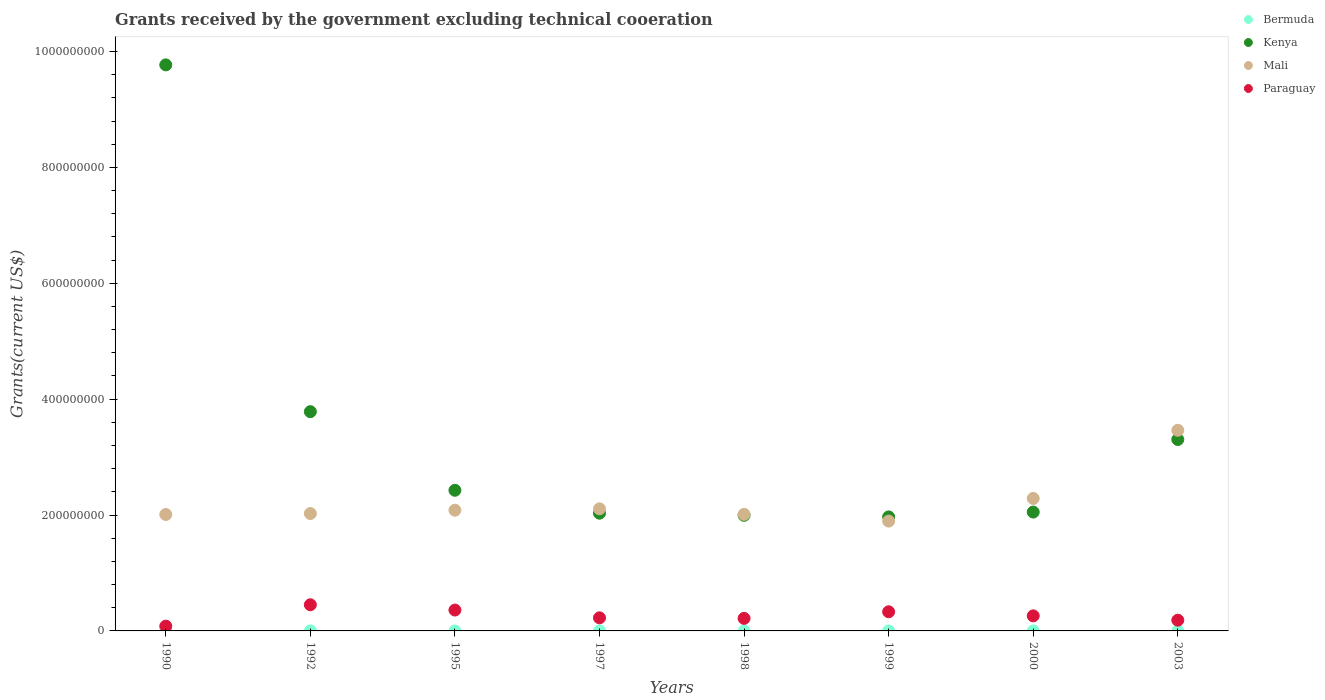What is the total grants received by the government in Paraguay in 1997?
Your response must be concise. 2.26e+07. Across all years, what is the maximum total grants received by the government in Mali?
Give a very brief answer. 3.46e+08. Across all years, what is the minimum total grants received by the government in Paraguay?
Give a very brief answer. 8.24e+06. What is the total total grants received by the government in Kenya in the graph?
Your answer should be compact. 2.73e+09. What is the difference between the total grants received by the government in Kenya in 1990 and that in 1995?
Your response must be concise. 7.34e+08. What is the difference between the total grants received by the government in Kenya in 2003 and the total grants received by the government in Bermuda in 1995?
Offer a very short reply. 3.30e+08. What is the average total grants received by the government in Mali per year?
Provide a short and direct response. 2.24e+08. In the year 1998, what is the difference between the total grants received by the government in Kenya and total grants received by the government in Paraguay?
Keep it short and to the point. 1.78e+08. In how many years, is the total grants received by the government in Paraguay greater than 80000000 US$?
Provide a short and direct response. 0. What is the ratio of the total grants received by the government in Kenya in 1990 to that in 1998?
Provide a short and direct response. 4.9. Is the difference between the total grants received by the government in Kenya in 1990 and 2003 greater than the difference between the total grants received by the government in Paraguay in 1990 and 2003?
Your answer should be very brief. Yes. What is the difference between the highest and the second highest total grants received by the government in Kenya?
Provide a short and direct response. 5.99e+08. What is the difference between the highest and the lowest total grants received by the government in Paraguay?
Ensure brevity in your answer.  3.69e+07. In how many years, is the total grants received by the government in Bermuda greater than the average total grants received by the government in Bermuda taken over all years?
Keep it short and to the point. 2. Is the sum of the total grants received by the government in Mali in 1998 and 1999 greater than the maximum total grants received by the government in Bermuda across all years?
Offer a terse response. Yes. Is it the case that in every year, the sum of the total grants received by the government in Bermuda and total grants received by the government in Paraguay  is greater than the sum of total grants received by the government in Kenya and total grants received by the government in Mali?
Provide a succinct answer. No. Is the total grants received by the government in Bermuda strictly less than the total grants received by the government in Kenya over the years?
Keep it short and to the point. Yes. What is the difference between two consecutive major ticks on the Y-axis?
Ensure brevity in your answer.  2.00e+08. Are the values on the major ticks of Y-axis written in scientific E-notation?
Make the answer very short. No. Does the graph contain grids?
Offer a terse response. No. Where does the legend appear in the graph?
Make the answer very short. Top right. How are the legend labels stacked?
Make the answer very short. Vertical. What is the title of the graph?
Ensure brevity in your answer.  Grants received by the government excluding technical cooeration. Does "Cambodia" appear as one of the legend labels in the graph?
Give a very brief answer. No. What is the label or title of the X-axis?
Your answer should be very brief. Years. What is the label or title of the Y-axis?
Provide a succinct answer. Grants(current US$). What is the Grants(current US$) in Kenya in 1990?
Make the answer very short. 9.77e+08. What is the Grants(current US$) in Mali in 1990?
Offer a terse response. 2.01e+08. What is the Grants(current US$) in Paraguay in 1990?
Provide a succinct answer. 8.24e+06. What is the Grants(current US$) in Bermuda in 1992?
Your answer should be compact. 1.10e+05. What is the Grants(current US$) of Kenya in 1992?
Your answer should be very brief. 3.78e+08. What is the Grants(current US$) in Mali in 1992?
Provide a succinct answer. 2.03e+08. What is the Grants(current US$) of Paraguay in 1992?
Your answer should be very brief. 4.51e+07. What is the Grants(current US$) of Kenya in 1995?
Provide a succinct answer. 2.43e+08. What is the Grants(current US$) in Mali in 1995?
Your answer should be compact. 2.08e+08. What is the Grants(current US$) of Paraguay in 1995?
Offer a very short reply. 3.60e+07. What is the Grants(current US$) in Kenya in 1997?
Give a very brief answer. 2.03e+08. What is the Grants(current US$) of Mali in 1997?
Keep it short and to the point. 2.11e+08. What is the Grants(current US$) of Paraguay in 1997?
Offer a very short reply. 2.26e+07. What is the Grants(current US$) of Bermuda in 1998?
Offer a terse response. 10000. What is the Grants(current US$) in Kenya in 1998?
Make the answer very short. 2.00e+08. What is the Grants(current US$) of Mali in 1998?
Keep it short and to the point. 2.01e+08. What is the Grants(current US$) of Paraguay in 1998?
Make the answer very short. 2.17e+07. What is the Grants(current US$) of Bermuda in 1999?
Offer a very short reply. 10000. What is the Grants(current US$) of Kenya in 1999?
Your answer should be very brief. 1.97e+08. What is the Grants(current US$) of Mali in 1999?
Make the answer very short. 1.90e+08. What is the Grants(current US$) of Paraguay in 1999?
Offer a terse response. 3.30e+07. What is the Grants(current US$) of Bermuda in 2000?
Your answer should be compact. 3.00e+04. What is the Grants(current US$) of Kenya in 2000?
Offer a very short reply. 2.05e+08. What is the Grants(current US$) in Mali in 2000?
Your response must be concise. 2.29e+08. What is the Grants(current US$) of Paraguay in 2000?
Your answer should be very brief. 2.60e+07. What is the Grants(current US$) in Bermuda in 2003?
Ensure brevity in your answer.  10000. What is the Grants(current US$) in Kenya in 2003?
Provide a succinct answer. 3.30e+08. What is the Grants(current US$) in Mali in 2003?
Your answer should be compact. 3.46e+08. What is the Grants(current US$) of Paraguay in 2003?
Your answer should be compact. 1.85e+07. Across all years, what is the maximum Grants(current US$) in Kenya?
Provide a short and direct response. 9.77e+08. Across all years, what is the maximum Grants(current US$) in Mali?
Provide a short and direct response. 3.46e+08. Across all years, what is the maximum Grants(current US$) in Paraguay?
Your answer should be very brief. 4.51e+07. Across all years, what is the minimum Grants(current US$) in Kenya?
Give a very brief answer. 1.97e+08. Across all years, what is the minimum Grants(current US$) in Mali?
Offer a terse response. 1.90e+08. Across all years, what is the minimum Grants(current US$) in Paraguay?
Your answer should be compact. 8.24e+06. What is the total Grants(current US$) in Bermuda in the graph?
Your answer should be very brief. 2.80e+05. What is the total Grants(current US$) in Kenya in the graph?
Your response must be concise. 2.73e+09. What is the total Grants(current US$) in Mali in the graph?
Keep it short and to the point. 1.79e+09. What is the total Grants(current US$) of Paraguay in the graph?
Keep it short and to the point. 2.11e+08. What is the difference between the Grants(current US$) in Bermuda in 1990 and that in 1992?
Offer a terse response. -10000. What is the difference between the Grants(current US$) in Kenya in 1990 and that in 1992?
Your answer should be very brief. 5.99e+08. What is the difference between the Grants(current US$) of Mali in 1990 and that in 1992?
Your answer should be very brief. -1.66e+06. What is the difference between the Grants(current US$) of Paraguay in 1990 and that in 1992?
Your response must be concise. -3.69e+07. What is the difference between the Grants(current US$) of Kenya in 1990 and that in 1995?
Your answer should be very brief. 7.34e+08. What is the difference between the Grants(current US$) of Mali in 1990 and that in 1995?
Your response must be concise. -7.42e+06. What is the difference between the Grants(current US$) of Paraguay in 1990 and that in 1995?
Offer a very short reply. -2.78e+07. What is the difference between the Grants(current US$) of Bermuda in 1990 and that in 1997?
Provide a short and direct response. 9.00e+04. What is the difference between the Grants(current US$) of Kenya in 1990 and that in 1997?
Provide a short and direct response. 7.74e+08. What is the difference between the Grants(current US$) of Mali in 1990 and that in 1997?
Give a very brief answer. -9.80e+06. What is the difference between the Grants(current US$) in Paraguay in 1990 and that in 1997?
Make the answer very short. -1.44e+07. What is the difference between the Grants(current US$) of Kenya in 1990 and that in 1998?
Offer a terse response. 7.77e+08. What is the difference between the Grants(current US$) of Mali in 1990 and that in 1998?
Offer a very short reply. -2.20e+05. What is the difference between the Grants(current US$) of Paraguay in 1990 and that in 1998?
Your response must be concise. -1.34e+07. What is the difference between the Grants(current US$) of Kenya in 1990 and that in 1999?
Your response must be concise. 7.80e+08. What is the difference between the Grants(current US$) in Mali in 1990 and that in 1999?
Make the answer very short. 1.14e+07. What is the difference between the Grants(current US$) of Paraguay in 1990 and that in 1999?
Provide a succinct answer. -2.48e+07. What is the difference between the Grants(current US$) of Kenya in 1990 and that in 2000?
Provide a succinct answer. 7.72e+08. What is the difference between the Grants(current US$) of Mali in 1990 and that in 2000?
Keep it short and to the point. -2.77e+07. What is the difference between the Grants(current US$) in Paraguay in 1990 and that in 2000?
Give a very brief answer. -1.78e+07. What is the difference between the Grants(current US$) in Kenya in 1990 and that in 2003?
Your response must be concise. 6.47e+08. What is the difference between the Grants(current US$) in Mali in 1990 and that in 2003?
Your response must be concise. -1.45e+08. What is the difference between the Grants(current US$) in Paraguay in 1990 and that in 2003?
Ensure brevity in your answer.  -1.03e+07. What is the difference between the Grants(current US$) of Kenya in 1992 and that in 1995?
Provide a succinct answer. 1.36e+08. What is the difference between the Grants(current US$) in Mali in 1992 and that in 1995?
Provide a succinct answer. -5.76e+06. What is the difference between the Grants(current US$) in Paraguay in 1992 and that in 1995?
Keep it short and to the point. 9.10e+06. What is the difference between the Grants(current US$) in Bermuda in 1992 and that in 1997?
Give a very brief answer. 1.00e+05. What is the difference between the Grants(current US$) of Kenya in 1992 and that in 1997?
Ensure brevity in your answer.  1.75e+08. What is the difference between the Grants(current US$) in Mali in 1992 and that in 1997?
Ensure brevity in your answer.  -8.14e+06. What is the difference between the Grants(current US$) of Paraguay in 1992 and that in 1997?
Offer a terse response. 2.25e+07. What is the difference between the Grants(current US$) of Bermuda in 1992 and that in 1998?
Your answer should be compact. 1.00e+05. What is the difference between the Grants(current US$) in Kenya in 1992 and that in 1998?
Offer a terse response. 1.79e+08. What is the difference between the Grants(current US$) in Mali in 1992 and that in 1998?
Offer a very short reply. 1.44e+06. What is the difference between the Grants(current US$) in Paraguay in 1992 and that in 1998?
Your answer should be compact. 2.35e+07. What is the difference between the Grants(current US$) of Kenya in 1992 and that in 1999?
Your answer should be compact. 1.82e+08. What is the difference between the Grants(current US$) of Mali in 1992 and that in 1999?
Give a very brief answer. 1.31e+07. What is the difference between the Grants(current US$) in Paraguay in 1992 and that in 1999?
Your answer should be very brief. 1.21e+07. What is the difference between the Grants(current US$) of Bermuda in 1992 and that in 2000?
Provide a short and direct response. 8.00e+04. What is the difference between the Grants(current US$) in Kenya in 1992 and that in 2000?
Provide a succinct answer. 1.73e+08. What is the difference between the Grants(current US$) of Mali in 1992 and that in 2000?
Keep it short and to the point. -2.60e+07. What is the difference between the Grants(current US$) of Paraguay in 1992 and that in 2000?
Your response must be concise. 1.91e+07. What is the difference between the Grants(current US$) in Bermuda in 1992 and that in 2003?
Make the answer very short. 1.00e+05. What is the difference between the Grants(current US$) of Kenya in 1992 and that in 2003?
Provide a short and direct response. 4.80e+07. What is the difference between the Grants(current US$) of Mali in 1992 and that in 2003?
Make the answer very short. -1.44e+08. What is the difference between the Grants(current US$) of Paraguay in 1992 and that in 2003?
Keep it short and to the point. 2.66e+07. What is the difference between the Grants(current US$) in Kenya in 1995 and that in 1997?
Keep it short and to the point. 3.96e+07. What is the difference between the Grants(current US$) of Mali in 1995 and that in 1997?
Provide a succinct answer. -2.38e+06. What is the difference between the Grants(current US$) in Paraguay in 1995 and that in 1997?
Your answer should be very brief. 1.34e+07. What is the difference between the Grants(current US$) of Kenya in 1995 and that in 1998?
Ensure brevity in your answer.  4.32e+07. What is the difference between the Grants(current US$) of Mali in 1995 and that in 1998?
Make the answer very short. 7.20e+06. What is the difference between the Grants(current US$) in Paraguay in 1995 and that in 1998?
Provide a succinct answer. 1.44e+07. What is the difference between the Grants(current US$) in Kenya in 1995 and that in 1999?
Your answer should be very brief. 4.60e+07. What is the difference between the Grants(current US$) in Mali in 1995 and that in 1999?
Keep it short and to the point. 1.88e+07. What is the difference between the Grants(current US$) of Paraguay in 1995 and that in 1999?
Make the answer very short. 2.98e+06. What is the difference between the Grants(current US$) in Kenya in 1995 and that in 2000?
Keep it short and to the point. 3.76e+07. What is the difference between the Grants(current US$) in Mali in 1995 and that in 2000?
Keep it short and to the point. -2.03e+07. What is the difference between the Grants(current US$) in Paraguay in 1995 and that in 2000?
Keep it short and to the point. 1.00e+07. What is the difference between the Grants(current US$) of Kenya in 1995 and that in 2003?
Your answer should be very brief. -8.76e+07. What is the difference between the Grants(current US$) of Mali in 1995 and that in 2003?
Provide a short and direct response. -1.38e+08. What is the difference between the Grants(current US$) in Paraguay in 1995 and that in 2003?
Your answer should be very brief. 1.75e+07. What is the difference between the Grants(current US$) in Bermuda in 1997 and that in 1998?
Your answer should be compact. 0. What is the difference between the Grants(current US$) of Kenya in 1997 and that in 1998?
Your answer should be very brief. 3.70e+06. What is the difference between the Grants(current US$) in Mali in 1997 and that in 1998?
Make the answer very short. 9.58e+06. What is the difference between the Grants(current US$) in Paraguay in 1997 and that in 1998?
Offer a very short reply. 9.50e+05. What is the difference between the Grants(current US$) in Kenya in 1997 and that in 1999?
Ensure brevity in your answer.  6.43e+06. What is the difference between the Grants(current US$) of Mali in 1997 and that in 1999?
Provide a short and direct response. 2.12e+07. What is the difference between the Grants(current US$) in Paraguay in 1997 and that in 1999?
Your response must be concise. -1.04e+07. What is the difference between the Grants(current US$) in Bermuda in 1997 and that in 2000?
Your answer should be very brief. -2.00e+04. What is the difference between the Grants(current US$) of Kenya in 1997 and that in 2000?
Offer a terse response. -1.93e+06. What is the difference between the Grants(current US$) in Mali in 1997 and that in 2000?
Offer a very short reply. -1.79e+07. What is the difference between the Grants(current US$) of Paraguay in 1997 and that in 2000?
Provide a succinct answer. -3.41e+06. What is the difference between the Grants(current US$) in Kenya in 1997 and that in 2003?
Offer a very short reply. -1.27e+08. What is the difference between the Grants(current US$) in Mali in 1997 and that in 2003?
Keep it short and to the point. -1.36e+08. What is the difference between the Grants(current US$) of Paraguay in 1997 and that in 2003?
Offer a very short reply. 4.08e+06. What is the difference between the Grants(current US$) of Bermuda in 1998 and that in 1999?
Offer a terse response. 0. What is the difference between the Grants(current US$) of Kenya in 1998 and that in 1999?
Your answer should be compact. 2.73e+06. What is the difference between the Grants(current US$) of Mali in 1998 and that in 1999?
Offer a very short reply. 1.16e+07. What is the difference between the Grants(current US$) in Paraguay in 1998 and that in 1999?
Your answer should be compact. -1.14e+07. What is the difference between the Grants(current US$) in Kenya in 1998 and that in 2000?
Make the answer very short. -5.63e+06. What is the difference between the Grants(current US$) of Mali in 1998 and that in 2000?
Ensure brevity in your answer.  -2.75e+07. What is the difference between the Grants(current US$) in Paraguay in 1998 and that in 2000?
Make the answer very short. -4.36e+06. What is the difference between the Grants(current US$) in Bermuda in 1998 and that in 2003?
Your answer should be compact. 0. What is the difference between the Grants(current US$) in Kenya in 1998 and that in 2003?
Your answer should be very brief. -1.31e+08. What is the difference between the Grants(current US$) in Mali in 1998 and that in 2003?
Offer a very short reply. -1.45e+08. What is the difference between the Grants(current US$) in Paraguay in 1998 and that in 2003?
Your response must be concise. 3.13e+06. What is the difference between the Grants(current US$) of Kenya in 1999 and that in 2000?
Keep it short and to the point. -8.36e+06. What is the difference between the Grants(current US$) in Mali in 1999 and that in 2000?
Give a very brief answer. -3.91e+07. What is the difference between the Grants(current US$) in Paraguay in 1999 and that in 2000?
Make the answer very short. 7.03e+06. What is the difference between the Grants(current US$) in Bermuda in 1999 and that in 2003?
Your response must be concise. 0. What is the difference between the Grants(current US$) in Kenya in 1999 and that in 2003?
Provide a succinct answer. -1.34e+08. What is the difference between the Grants(current US$) of Mali in 1999 and that in 2003?
Ensure brevity in your answer.  -1.57e+08. What is the difference between the Grants(current US$) in Paraguay in 1999 and that in 2003?
Ensure brevity in your answer.  1.45e+07. What is the difference between the Grants(current US$) in Bermuda in 2000 and that in 2003?
Ensure brevity in your answer.  2.00e+04. What is the difference between the Grants(current US$) of Kenya in 2000 and that in 2003?
Ensure brevity in your answer.  -1.25e+08. What is the difference between the Grants(current US$) in Mali in 2000 and that in 2003?
Your answer should be compact. -1.18e+08. What is the difference between the Grants(current US$) of Paraguay in 2000 and that in 2003?
Provide a short and direct response. 7.49e+06. What is the difference between the Grants(current US$) in Bermuda in 1990 and the Grants(current US$) in Kenya in 1992?
Keep it short and to the point. -3.78e+08. What is the difference between the Grants(current US$) in Bermuda in 1990 and the Grants(current US$) in Mali in 1992?
Provide a succinct answer. -2.03e+08. What is the difference between the Grants(current US$) of Bermuda in 1990 and the Grants(current US$) of Paraguay in 1992?
Your answer should be compact. -4.50e+07. What is the difference between the Grants(current US$) of Kenya in 1990 and the Grants(current US$) of Mali in 1992?
Keep it short and to the point. 7.74e+08. What is the difference between the Grants(current US$) of Kenya in 1990 and the Grants(current US$) of Paraguay in 1992?
Provide a succinct answer. 9.32e+08. What is the difference between the Grants(current US$) of Mali in 1990 and the Grants(current US$) of Paraguay in 1992?
Offer a terse response. 1.56e+08. What is the difference between the Grants(current US$) in Bermuda in 1990 and the Grants(current US$) in Kenya in 1995?
Provide a short and direct response. -2.43e+08. What is the difference between the Grants(current US$) of Bermuda in 1990 and the Grants(current US$) of Mali in 1995?
Give a very brief answer. -2.08e+08. What is the difference between the Grants(current US$) in Bermuda in 1990 and the Grants(current US$) in Paraguay in 1995?
Ensure brevity in your answer.  -3.59e+07. What is the difference between the Grants(current US$) of Kenya in 1990 and the Grants(current US$) of Mali in 1995?
Ensure brevity in your answer.  7.69e+08. What is the difference between the Grants(current US$) in Kenya in 1990 and the Grants(current US$) in Paraguay in 1995?
Offer a terse response. 9.41e+08. What is the difference between the Grants(current US$) of Mali in 1990 and the Grants(current US$) of Paraguay in 1995?
Keep it short and to the point. 1.65e+08. What is the difference between the Grants(current US$) of Bermuda in 1990 and the Grants(current US$) of Kenya in 1997?
Ensure brevity in your answer.  -2.03e+08. What is the difference between the Grants(current US$) in Bermuda in 1990 and the Grants(current US$) in Mali in 1997?
Provide a succinct answer. -2.11e+08. What is the difference between the Grants(current US$) of Bermuda in 1990 and the Grants(current US$) of Paraguay in 1997?
Make the answer very short. -2.25e+07. What is the difference between the Grants(current US$) of Kenya in 1990 and the Grants(current US$) of Mali in 1997?
Provide a short and direct response. 7.66e+08. What is the difference between the Grants(current US$) in Kenya in 1990 and the Grants(current US$) in Paraguay in 1997?
Provide a succinct answer. 9.54e+08. What is the difference between the Grants(current US$) of Mali in 1990 and the Grants(current US$) of Paraguay in 1997?
Provide a short and direct response. 1.78e+08. What is the difference between the Grants(current US$) of Bermuda in 1990 and the Grants(current US$) of Kenya in 1998?
Offer a terse response. -1.99e+08. What is the difference between the Grants(current US$) in Bermuda in 1990 and the Grants(current US$) in Mali in 1998?
Provide a succinct answer. -2.01e+08. What is the difference between the Grants(current US$) of Bermuda in 1990 and the Grants(current US$) of Paraguay in 1998?
Give a very brief answer. -2.16e+07. What is the difference between the Grants(current US$) of Kenya in 1990 and the Grants(current US$) of Mali in 1998?
Provide a succinct answer. 7.76e+08. What is the difference between the Grants(current US$) in Kenya in 1990 and the Grants(current US$) in Paraguay in 1998?
Ensure brevity in your answer.  9.55e+08. What is the difference between the Grants(current US$) in Mali in 1990 and the Grants(current US$) in Paraguay in 1998?
Make the answer very short. 1.79e+08. What is the difference between the Grants(current US$) of Bermuda in 1990 and the Grants(current US$) of Kenya in 1999?
Provide a succinct answer. -1.97e+08. What is the difference between the Grants(current US$) of Bermuda in 1990 and the Grants(current US$) of Mali in 1999?
Provide a succinct answer. -1.89e+08. What is the difference between the Grants(current US$) in Bermuda in 1990 and the Grants(current US$) in Paraguay in 1999?
Ensure brevity in your answer.  -3.30e+07. What is the difference between the Grants(current US$) of Kenya in 1990 and the Grants(current US$) of Mali in 1999?
Ensure brevity in your answer.  7.87e+08. What is the difference between the Grants(current US$) of Kenya in 1990 and the Grants(current US$) of Paraguay in 1999?
Provide a succinct answer. 9.44e+08. What is the difference between the Grants(current US$) of Mali in 1990 and the Grants(current US$) of Paraguay in 1999?
Provide a short and direct response. 1.68e+08. What is the difference between the Grants(current US$) of Bermuda in 1990 and the Grants(current US$) of Kenya in 2000?
Provide a succinct answer. -2.05e+08. What is the difference between the Grants(current US$) of Bermuda in 1990 and the Grants(current US$) of Mali in 2000?
Give a very brief answer. -2.29e+08. What is the difference between the Grants(current US$) in Bermuda in 1990 and the Grants(current US$) in Paraguay in 2000?
Offer a very short reply. -2.59e+07. What is the difference between the Grants(current US$) in Kenya in 1990 and the Grants(current US$) in Mali in 2000?
Provide a short and direct response. 7.48e+08. What is the difference between the Grants(current US$) of Kenya in 1990 and the Grants(current US$) of Paraguay in 2000?
Your answer should be very brief. 9.51e+08. What is the difference between the Grants(current US$) in Mali in 1990 and the Grants(current US$) in Paraguay in 2000?
Keep it short and to the point. 1.75e+08. What is the difference between the Grants(current US$) in Bermuda in 1990 and the Grants(current US$) in Kenya in 2003?
Your answer should be compact. -3.30e+08. What is the difference between the Grants(current US$) of Bermuda in 1990 and the Grants(current US$) of Mali in 2003?
Give a very brief answer. -3.46e+08. What is the difference between the Grants(current US$) of Bermuda in 1990 and the Grants(current US$) of Paraguay in 2003?
Offer a very short reply. -1.84e+07. What is the difference between the Grants(current US$) in Kenya in 1990 and the Grants(current US$) in Mali in 2003?
Your answer should be compact. 6.31e+08. What is the difference between the Grants(current US$) in Kenya in 1990 and the Grants(current US$) in Paraguay in 2003?
Your response must be concise. 9.58e+08. What is the difference between the Grants(current US$) in Mali in 1990 and the Grants(current US$) in Paraguay in 2003?
Your answer should be compact. 1.82e+08. What is the difference between the Grants(current US$) in Bermuda in 1992 and the Grants(current US$) in Kenya in 1995?
Your answer should be very brief. -2.43e+08. What is the difference between the Grants(current US$) in Bermuda in 1992 and the Grants(current US$) in Mali in 1995?
Your answer should be very brief. -2.08e+08. What is the difference between the Grants(current US$) in Bermuda in 1992 and the Grants(current US$) in Paraguay in 1995?
Make the answer very short. -3.59e+07. What is the difference between the Grants(current US$) of Kenya in 1992 and the Grants(current US$) of Mali in 1995?
Keep it short and to the point. 1.70e+08. What is the difference between the Grants(current US$) in Kenya in 1992 and the Grants(current US$) in Paraguay in 1995?
Give a very brief answer. 3.42e+08. What is the difference between the Grants(current US$) of Mali in 1992 and the Grants(current US$) of Paraguay in 1995?
Give a very brief answer. 1.67e+08. What is the difference between the Grants(current US$) in Bermuda in 1992 and the Grants(current US$) in Kenya in 1997?
Make the answer very short. -2.03e+08. What is the difference between the Grants(current US$) of Bermuda in 1992 and the Grants(current US$) of Mali in 1997?
Your answer should be very brief. -2.11e+08. What is the difference between the Grants(current US$) in Bermuda in 1992 and the Grants(current US$) in Paraguay in 1997?
Your answer should be compact. -2.25e+07. What is the difference between the Grants(current US$) of Kenya in 1992 and the Grants(current US$) of Mali in 1997?
Offer a terse response. 1.68e+08. What is the difference between the Grants(current US$) of Kenya in 1992 and the Grants(current US$) of Paraguay in 1997?
Your answer should be compact. 3.56e+08. What is the difference between the Grants(current US$) in Mali in 1992 and the Grants(current US$) in Paraguay in 1997?
Your answer should be compact. 1.80e+08. What is the difference between the Grants(current US$) of Bermuda in 1992 and the Grants(current US$) of Kenya in 1998?
Give a very brief answer. -1.99e+08. What is the difference between the Grants(current US$) of Bermuda in 1992 and the Grants(current US$) of Mali in 1998?
Provide a succinct answer. -2.01e+08. What is the difference between the Grants(current US$) in Bermuda in 1992 and the Grants(current US$) in Paraguay in 1998?
Keep it short and to the point. -2.16e+07. What is the difference between the Grants(current US$) in Kenya in 1992 and the Grants(current US$) in Mali in 1998?
Give a very brief answer. 1.77e+08. What is the difference between the Grants(current US$) in Kenya in 1992 and the Grants(current US$) in Paraguay in 1998?
Give a very brief answer. 3.57e+08. What is the difference between the Grants(current US$) in Mali in 1992 and the Grants(current US$) in Paraguay in 1998?
Give a very brief answer. 1.81e+08. What is the difference between the Grants(current US$) of Bermuda in 1992 and the Grants(current US$) of Kenya in 1999?
Give a very brief answer. -1.97e+08. What is the difference between the Grants(current US$) in Bermuda in 1992 and the Grants(current US$) in Mali in 1999?
Your answer should be very brief. -1.89e+08. What is the difference between the Grants(current US$) in Bermuda in 1992 and the Grants(current US$) in Paraguay in 1999?
Offer a very short reply. -3.29e+07. What is the difference between the Grants(current US$) in Kenya in 1992 and the Grants(current US$) in Mali in 1999?
Offer a very short reply. 1.89e+08. What is the difference between the Grants(current US$) in Kenya in 1992 and the Grants(current US$) in Paraguay in 1999?
Offer a terse response. 3.45e+08. What is the difference between the Grants(current US$) of Mali in 1992 and the Grants(current US$) of Paraguay in 1999?
Ensure brevity in your answer.  1.70e+08. What is the difference between the Grants(current US$) in Bermuda in 1992 and the Grants(current US$) in Kenya in 2000?
Your answer should be compact. -2.05e+08. What is the difference between the Grants(current US$) of Bermuda in 1992 and the Grants(current US$) of Mali in 2000?
Your answer should be compact. -2.29e+08. What is the difference between the Grants(current US$) in Bermuda in 1992 and the Grants(current US$) in Paraguay in 2000?
Offer a terse response. -2.59e+07. What is the difference between the Grants(current US$) of Kenya in 1992 and the Grants(current US$) of Mali in 2000?
Ensure brevity in your answer.  1.50e+08. What is the difference between the Grants(current US$) of Kenya in 1992 and the Grants(current US$) of Paraguay in 2000?
Offer a very short reply. 3.52e+08. What is the difference between the Grants(current US$) of Mali in 1992 and the Grants(current US$) of Paraguay in 2000?
Ensure brevity in your answer.  1.77e+08. What is the difference between the Grants(current US$) in Bermuda in 1992 and the Grants(current US$) in Kenya in 2003?
Your answer should be compact. -3.30e+08. What is the difference between the Grants(current US$) of Bermuda in 1992 and the Grants(current US$) of Mali in 2003?
Ensure brevity in your answer.  -3.46e+08. What is the difference between the Grants(current US$) of Bermuda in 1992 and the Grants(current US$) of Paraguay in 2003?
Your response must be concise. -1.84e+07. What is the difference between the Grants(current US$) of Kenya in 1992 and the Grants(current US$) of Mali in 2003?
Your answer should be compact. 3.21e+07. What is the difference between the Grants(current US$) in Kenya in 1992 and the Grants(current US$) in Paraguay in 2003?
Offer a terse response. 3.60e+08. What is the difference between the Grants(current US$) of Mali in 1992 and the Grants(current US$) of Paraguay in 2003?
Provide a succinct answer. 1.84e+08. What is the difference between the Grants(current US$) of Kenya in 1995 and the Grants(current US$) of Mali in 1997?
Your response must be concise. 3.20e+07. What is the difference between the Grants(current US$) of Kenya in 1995 and the Grants(current US$) of Paraguay in 1997?
Your response must be concise. 2.20e+08. What is the difference between the Grants(current US$) of Mali in 1995 and the Grants(current US$) of Paraguay in 1997?
Your answer should be very brief. 1.86e+08. What is the difference between the Grants(current US$) of Kenya in 1995 and the Grants(current US$) of Mali in 1998?
Your response must be concise. 4.16e+07. What is the difference between the Grants(current US$) in Kenya in 1995 and the Grants(current US$) in Paraguay in 1998?
Your response must be concise. 2.21e+08. What is the difference between the Grants(current US$) in Mali in 1995 and the Grants(current US$) in Paraguay in 1998?
Give a very brief answer. 1.87e+08. What is the difference between the Grants(current US$) of Kenya in 1995 and the Grants(current US$) of Mali in 1999?
Provide a short and direct response. 5.32e+07. What is the difference between the Grants(current US$) in Kenya in 1995 and the Grants(current US$) in Paraguay in 1999?
Give a very brief answer. 2.10e+08. What is the difference between the Grants(current US$) of Mali in 1995 and the Grants(current US$) of Paraguay in 1999?
Provide a succinct answer. 1.75e+08. What is the difference between the Grants(current US$) in Kenya in 1995 and the Grants(current US$) in Mali in 2000?
Your answer should be very brief. 1.41e+07. What is the difference between the Grants(current US$) of Kenya in 1995 and the Grants(current US$) of Paraguay in 2000?
Keep it short and to the point. 2.17e+08. What is the difference between the Grants(current US$) of Mali in 1995 and the Grants(current US$) of Paraguay in 2000?
Ensure brevity in your answer.  1.82e+08. What is the difference between the Grants(current US$) in Kenya in 1995 and the Grants(current US$) in Mali in 2003?
Provide a succinct answer. -1.04e+08. What is the difference between the Grants(current US$) in Kenya in 1995 and the Grants(current US$) in Paraguay in 2003?
Your answer should be very brief. 2.24e+08. What is the difference between the Grants(current US$) of Mali in 1995 and the Grants(current US$) of Paraguay in 2003?
Offer a very short reply. 1.90e+08. What is the difference between the Grants(current US$) of Bermuda in 1997 and the Grants(current US$) of Kenya in 1998?
Provide a succinct answer. -1.99e+08. What is the difference between the Grants(current US$) of Bermuda in 1997 and the Grants(current US$) of Mali in 1998?
Give a very brief answer. -2.01e+08. What is the difference between the Grants(current US$) in Bermuda in 1997 and the Grants(current US$) in Paraguay in 1998?
Your response must be concise. -2.16e+07. What is the difference between the Grants(current US$) in Kenya in 1997 and the Grants(current US$) in Mali in 1998?
Provide a succinct answer. 2.03e+06. What is the difference between the Grants(current US$) in Kenya in 1997 and the Grants(current US$) in Paraguay in 1998?
Your response must be concise. 1.82e+08. What is the difference between the Grants(current US$) in Mali in 1997 and the Grants(current US$) in Paraguay in 1998?
Your response must be concise. 1.89e+08. What is the difference between the Grants(current US$) of Bermuda in 1997 and the Grants(current US$) of Kenya in 1999?
Provide a succinct answer. -1.97e+08. What is the difference between the Grants(current US$) of Bermuda in 1997 and the Grants(current US$) of Mali in 1999?
Your answer should be very brief. -1.90e+08. What is the difference between the Grants(current US$) in Bermuda in 1997 and the Grants(current US$) in Paraguay in 1999?
Offer a very short reply. -3.30e+07. What is the difference between the Grants(current US$) in Kenya in 1997 and the Grants(current US$) in Mali in 1999?
Offer a terse response. 1.37e+07. What is the difference between the Grants(current US$) in Kenya in 1997 and the Grants(current US$) in Paraguay in 1999?
Your answer should be compact. 1.70e+08. What is the difference between the Grants(current US$) of Mali in 1997 and the Grants(current US$) of Paraguay in 1999?
Provide a succinct answer. 1.78e+08. What is the difference between the Grants(current US$) of Bermuda in 1997 and the Grants(current US$) of Kenya in 2000?
Offer a very short reply. -2.05e+08. What is the difference between the Grants(current US$) in Bermuda in 1997 and the Grants(current US$) in Mali in 2000?
Ensure brevity in your answer.  -2.29e+08. What is the difference between the Grants(current US$) in Bermuda in 1997 and the Grants(current US$) in Paraguay in 2000?
Give a very brief answer. -2.60e+07. What is the difference between the Grants(current US$) in Kenya in 1997 and the Grants(current US$) in Mali in 2000?
Keep it short and to the point. -2.55e+07. What is the difference between the Grants(current US$) in Kenya in 1997 and the Grants(current US$) in Paraguay in 2000?
Keep it short and to the point. 1.77e+08. What is the difference between the Grants(current US$) in Mali in 1997 and the Grants(current US$) in Paraguay in 2000?
Give a very brief answer. 1.85e+08. What is the difference between the Grants(current US$) of Bermuda in 1997 and the Grants(current US$) of Kenya in 2003?
Offer a terse response. -3.30e+08. What is the difference between the Grants(current US$) of Bermuda in 1997 and the Grants(current US$) of Mali in 2003?
Your response must be concise. -3.46e+08. What is the difference between the Grants(current US$) of Bermuda in 1997 and the Grants(current US$) of Paraguay in 2003?
Offer a very short reply. -1.85e+07. What is the difference between the Grants(current US$) in Kenya in 1997 and the Grants(current US$) in Mali in 2003?
Make the answer very short. -1.43e+08. What is the difference between the Grants(current US$) in Kenya in 1997 and the Grants(current US$) in Paraguay in 2003?
Offer a terse response. 1.85e+08. What is the difference between the Grants(current US$) of Mali in 1997 and the Grants(current US$) of Paraguay in 2003?
Offer a very short reply. 1.92e+08. What is the difference between the Grants(current US$) in Bermuda in 1998 and the Grants(current US$) in Kenya in 1999?
Your answer should be compact. -1.97e+08. What is the difference between the Grants(current US$) in Bermuda in 1998 and the Grants(current US$) in Mali in 1999?
Ensure brevity in your answer.  -1.90e+08. What is the difference between the Grants(current US$) in Bermuda in 1998 and the Grants(current US$) in Paraguay in 1999?
Your response must be concise. -3.30e+07. What is the difference between the Grants(current US$) of Kenya in 1998 and the Grants(current US$) of Mali in 1999?
Your answer should be very brief. 9.97e+06. What is the difference between the Grants(current US$) of Kenya in 1998 and the Grants(current US$) of Paraguay in 1999?
Provide a short and direct response. 1.66e+08. What is the difference between the Grants(current US$) of Mali in 1998 and the Grants(current US$) of Paraguay in 1999?
Provide a short and direct response. 1.68e+08. What is the difference between the Grants(current US$) in Bermuda in 1998 and the Grants(current US$) in Kenya in 2000?
Offer a very short reply. -2.05e+08. What is the difference between the Grants(current US$) of Bermuda in 1998 and the Grants(current US$) of Mali in 2000?
Your answer should be compact. -2.29e+08. What is the difference between the Grants(current US$) in Bermuda in 1998 and the Grants(current US$) in Paraguay in 2000?
Provide a short and direct response. -2.60e+07. What is the difference between the Grants(current US$) in Kenya in 1998 and the Grants(current US$) in Mali in 2000?
Offer a very short reply. -2.92e+07. What is the difference between the Grants(current US$) in Kenya in 1998 and the Grants(current US$) in Paraguay in 2000?
Provide a short and direct response. 1.73e+08. What is the difference between the Grants(current US$) in Mali in 1998 and the Grants(current US$) in Paraguay in 2000?
Provide a succinct answer. 1.75e+08. What is the difference between the Grants(current US$) in Bermuda in 1998 and the Grants(current US$) in Kenya in 2003?
Offer a terse response. -3.30e+08. What is the difference between the Grants(current US$) in Bermuda in 1998 and the Grants(current US$) in Mali in 2003?
Your answer should be compact. -3.46e+08. What is the difference between the Grants(current US$) in Bermuda in 1998 and the Grants(current US$) in Paraguay in 2003?
Your answer should be very brief. -1.85e+07. What is the difference between the Grants(current US$) of Kenya in 1998 and the Grants(current US$) of Mali in 2003?
Keep it short and to the point. -1.47e+08. What is the difference between the Grants(current US$) of Kenya in 1998 and the Grants(current US$) of Paraguay in 2003?
Give a very brief answer. 1.81e+08. What is the difference between the Grants(current US$) of Mali in 1998 and the Grants(current US$) of Paraguay in 2003?
Provide a short and direct response. 1.83e+08. What is the difference between the Grants(current US$) of Bermuda in 1999 and the Grants(current US$) of Kenya in 2000?
Give a very brief answer. -2.05e+08. What is the difference between the Grants(current US$) in Bermuda in 1999 and the Grants(current US$) in Mali in 2000?
Your answer should be compact. -2.29e+08. What is the difference between the Grants(current US$) of Bermuda in 1999 and the Grants(current US$) of Paraguay in 2000?
Offer a very short reply. -2.60e+07. What is the difference between the Grants(current US$) of Kenya in 1999 and the Grants(current US$) of Mali in 2000?
Give a very brief answer. -3.19e+07. What is the difference between the Grants(current US$) in Kenya in 1999 and the Grants(current US$) in Paraguay in 2000?
Give a very brief answer. 1.71e+08. What is the difference between the Grants(current US$) in Mali in 1999 and the Grants(current US$) in Paraguay in 2000?
Provide a short and direct response. 1.64e+08. What is the difference between the Grants(current US$) of Bermuda in 1999 and the Grants(current US$) of Kenya in 2003?
Your response must be concise. -3.30e+08. What is the difference between the Grants(current US$) in Bermuda in 1999 and the Grants(current US$) in Mali in 2003?
Your answer should be very brief. -3.46e+08. What is the difference between the Grants(current US$) of Bermuda in 1999 and the Grants(current US$) of Paraguay in 2003?
Offer a terse response. -1.85e+07. What is the difference between the Grants(current US$) of Kenya in 1999 and the Grants(current US$) of Mali in 2003?
Offer a very short reply. -1.50e+08. What is the difference between the Grants(current US$) of Kenya in 1999 and the Grants(current US$) of Paraguay in 2003?
Ensure brevity in your answer.  1.78e+08. What is the difference between the Grants(current US$) in Mali in 1999 and the Grants(current US$) in Paraguay in 2003?
Provide a succinct answer. 1.71e+08. What is the difference between the Grants(current US$) in Bermuda in 2000 and the Grants(current US$) in Kenya in 2003?
Offer a terse response. -3.30e+08. What is the difference between the Grants(current US$) of Bermuda in 2000 and the Grants(current US$) of Mali in 2003?
Offer a very short reply. -3.46e+08. What is the difference between the Grants(current US$) in Bermuda in 2000 and the Grants(current US$) in Paraguay in 2003?
Give a very brief answer. -1.85e+07. What is the difference between the Grants(current US$) of Kenya in 2000 and the Grants(current US$) of Mali in 2003?
Your answer should be compact. -1.41e+08. What is the difference between the Grants(current US$) of Kenya in 2000 and the Grants(current US$) of Paraguay in 2003?
Your response must be concise. 1.87e+08. What is the difference between the Grants(current US$) of Mali in 2000 and the Grants(current US$) of Paraguay in 2003?
Your answer should be very brief. 2.10e+08. What is the average Grants(current US$) in Bermuda per year?
Offer a terse response. 3.50e+04. What is the average Grants(current US$) in Kenya per year?
Your answer should be very brief. 3.42e+08. What is the average Grants(current US$) in Mali per year?
Your answer should be compact. 2.24e+08. What is the average Grants(current US$) of Paraguay per year?
Your answer should be very brief. 2.64e+07. In the year 1990, what is the difference between the Grants(current US$) of Bermuda and Grants(current US$) of Kenya?
Your answer should be compact. -9.77e+08. In the year 1990, what is the difference between the Grants(current US$) in Bermuda and Grants(current US$) in Mali?
Make the answer very short. -2.01e+08. In the year 1990, what is the difference between the Grants(current US$) of Bermuda and Grants(current US$) of Paraguay?
Keep it short and to the point. -8.14e+06. In the year 1990, what is the difference between the Grants(current US$) in Kenya and Grants(current US$) in Mali?
Offer a very short reply. 7.76e+08. In the year 1990, what is the difference between the Grants(current US$) of Kenya and Grants(current US$) of Paraguay?
Provide a succinct answer. 9.69e+08. In the year 1990, what is the difference between the Grants(current US$) of Mali and Grants(current US$) of Paraguay?
Ensure brevity in your answer.  1.93e+08. In the year 1992, what is the difference between the Grants(current US$) of Bermuda and Grants(current US$) of Kenya?
Your answer should be very brief. -3.78e+08. In the year 1992, what is the difference between the Grants(current US$) in Bermuda and Grants(current US$) in Mali?
Your answer should be compact. -2.02e+08. In the year 1992, what is the difference between the Grants(current US$) in Bermuda and Grants(current US$) in Paraguay?
Make the answer very short. -4.50e+07. In the year 1992, what is the difference between the Grants(current US$) in Kenya and Grants(current US$) in Mali?
Your response must be concise. 1.76e+08. In the year 1992, what is the difference between the Grants(current US$) of Kenya and Grants(current US$) of Paraguay?
Your answer should be compact. 3.33e+08. In the year 1992, what is the difference between the Grants(current US$) in Mali and Grants(current US$) in Paraguay?
Offer a terse response. 1.57e+08. In the year 1995, what is the difference between the Grants(current US$) of Kenya and Grants(current US$) of Mali?
Offer a very short reply. 3.44e+07. In the year 1995, what is the difference between the Grants(current US$) in Kenya and Grants(current US$) in Paraguay?
Give a very brief answer. 2.07e+08. In the year 1995, what is the difference between the Grants(current US$) of Mali and Grants(current US$) of Paraguay?
Keep it short and to the point. 1.72e+08. In the year 1997, what is the difference between the Grants(current US$) of Bermuda and Grants(current US$) of Kenya?
Give a very brief answer. -2.03e+08. In the year 1997, what is the difference between the Grants(current US$) of Bermuda and Grants(current US$) of Mali?
Your answer should be very brief. -2.11e+08. In the year 1997, what is the difference between the Grants(current US$) of Bermuda and Grants(current US$) of Paraguay?
Provide a short and direct response. -2.26e+07. In the year 1997, what is the difference between the Grants(current US$) of Kenya and Grants(current US$) of Mali?
Ensure brevity in your answer.  -7.55e+06. In the year 1997, what is the difference between the Grants(current US$) of Kenya and Grants(current US$) of Paraguay?
Your answer should be very brief. 1.81e+08. In the year 1997, what is the difference between the Grants(current US$) of Mali and Grants(current US$) of Paraguay?
Your response must be concise. 1.88e+08. In the year 1998, what is the difference between the Grants(current US$) of Bermuda and Grants(current US$) of Kenya?
Your response must be concise. -1.99e+08. In the year 1998, what is the difference between the Grants(current US$) of Bermuda and Grants(current US$) of Mali?
Offer a very short reply. -2.01e+08. In the year 1998, what is the difference between the Grants(current US$) of Bermuda and Grants(current US$) of Paraguay?
Make the answer very short. -2.16e+07. In the year 1998, what is the difference between the Grants(current US$) of Kenya and Grants(current US$) of Mali?
Provide a succinct answer. -1.67e+06. In the year 1998, what is the difference between the Grants(current US$) of Kenya and Grants(current US$) of Paraguay?
Provide a short and direct response. 1.78e+08. In the year 1998, what is the difference between the Grants(current US$) of Mali and Grants(current US$) of Paraguay?
Make the answer very short. 1.80e+08. In the year 1999, what is the difference between the Grants(current US$) of Bermuda and Grants(current US$) of Kenya?
Give a very brief answer. -1.97e+08. In the year 1999, what is the difference between the Grants(current US$) of Bermuda and Grants(current US$) of Mali?
Give a very brief answer. -1.90e+08. In the year 1999, what is the difference between the Grants(current US$) of Bermuda and Grants(current US$) of Paraguay?
Ensure brevity in your answer.  -3.30e+07. In the year 1999, what is the difference between the Grants(current US$) of Kenya and Grants(current US$) of Mali?
Provide a short and direct response. 7.24e+06. In the year 1999, what is the difference between the Grants(current US$) in Kenya and Grants(current US$) in Paraguay?
Offer a terse response. 1.64e+08. In the year 1999, what is the difference between the Grants(current US$) in Mali and Grants(current US$) in Paraguay?
Provide a succinct answer. 1.56e+08. In the year 2000, what is the difference between the Grants(current US$) of Bermuda and Grants(current US$) of Kenya?
Keep it short and to the point. -2.05e+08. In the year 2000, what is the difference between the Grants(current US$) of Bermuda and Grants(current US$) of Mali?
Offer a very short reply. -2.29e+08. In the year 2000, what is the difference between the Grants(current US$) in Bermuda and Grants(current US$) in Paraguay?
Make the answer very short. -2.60e+07. In the year 2000, what is the difference between the Grants(current US$) of Kenya and Grants(current US$) of Mali?
Offer a terse response. -2.35e+07. In the year 2000, what is the difference between the Grants(current US$) of Kenya and Grants(current US$) of Paraguay?
Provide a succinct answer. 1.79e+08. In the year 2000, what is the difference between the Grants(current US$) of Mali and Grants(current US$) of Paraguay?
Make the answer very short. 2.03e+08. In the year 2003, what is the difference between the Grants(current US$) of Bermuda and Grants(current US$) of Kenya?
Provide a succinct answer. -3.30e+08. In the year 2003, what is the difference between the Grants(current US$) of Bermuda and Grants(current US$) of Mali?
Ensure brevity in your answer.  -3.46e+08. In the year 2003, what is the difference between the Grants(current US$) in Bermuda and Grants(current US$) in Paraguay?
Offer a terse response. -1.85e+07. In the year 2003, what is the difference between the Grants(current US$) of Kenya and Grants(current US$) of Mali?
Offer a terse response. -1.59e+07. In the year 2003, what is the difference between the Grants(current US$) of Kenya and Grants(current US$) of Paraguay?
Your answer should be very brief. 3.12e+08. In the year 2003, what is the difference between the Grants(current US$) of Mali and Grants(current US$) of Paraguay?
Offer a very short reply. 3.28e+08. What is the ratio of the Grants(current US$) in Bermuda in 1990 to that in 1992?
Give a very brief answer. 0.91. What is the ratio of the Grants(current US$) of Kenya in 1990 to that in 1992?
Your answer should be compact. 2.58. What is the ratio of the Grants(current US$) of Paraguay in 1990 to that in 1992?
Give a very brief answer. 0.18. What is the ratio of the Grants(current US$) in Kenya in 1990 to that in 1995?
Make the answer very short. 4.02. What is the ratio of the Grants(current US$) of Mali in 1990 to that in 1995?
Your answer should be compact. 0.96. What is the ratio of the Grants(current US$) in Paraguay in 1990 to that in 1995?
Provide a short and direct response. 0.23. What is the ratio of the Grants(current US$) of Bermuda in 1990 to that in 1997?
Give a very brief answer. 10. What is the ratio of the Grants(current US$) of Kenya in 1990 to that in 1997?
Make the answer very short. 4.81. What is the ratio of the Grants(current US$) of Mali in 1990 to that in 1997?
Keep it short and to the point. 0.95. What is the ratio of the Grants(current US$) of Paraguay in 1990 to that in 1997?
Provide a short and direct response. 0.36. What is the ratio of the Grants(current US$) in Kenya in 1990 to that in 1998?
Your answer should be very brief. 4.9. What is the ratio of the Grants(current US$) of Paraguay in 1990 to that in 1998?
Offer a very short reply. 0.38. What is the ratio of the Grants(current US$) in Bermuda in 1990 to that in 1999?
Your answer should be compact. 10. What is the ratio of the Grants(current US$) of Kenya in 1990 to that in 1999?
Keep it short and to the point. 4.96. What is the ratio of the Grants(current US$) in Mali in 1990 to that in 1999?
Provide a short and direct response. 1.06. What is the ratio of the Grants(current US$) in Paraguay in 1990 to that in 1999?
Your answer should be very brief. 0.25. What is the ratio of the Grants(current US$) of Bermuda in 1990 to that in 2000?
Offer a terse response. 3.33. What is the ratio of the Grants(current US$) in Kenya in 1990 to that in 2000?
Make the answer very short. 4.76. What is the ratio of the Grants(current US$) in Mali in 1990 to that in 2000?
Offer a terse response. 0.88. What is the ratio of the Grants(current US$) of Paraguay in 1990 to that in 2000?
Give a very brief answer. 0.32. What is the ratio of the Grants(current US$) in Kenya in 1990 to that in 2003?
Your response must be concise. 2.96. What is the ratio of the Grants(current US$) in Mali in 1990 to that in 2003?
Offer a terse response. 0.58. What is the ratio of the Grants(current US$) in Paraguay in 1990 to that in 2003?
Your answer should be compact. 0.44. What is the ratio of the Grants(current US$) in Kenya in 1992 to that in 1995?
Offer a terse response. 1.56. What is the ratio of the Grants(current US$) of Mali in 1992 to that in 1995?
Offer a terse response. 0.97. What is the ratio of the Grants(current US$) of Paraguay in 1992 to that in 1995?
Your answer should be compact. 1.25. What is the ratio of the Grants(current US$) in Kenya in 1992 to that in 1997?
Offer a terse response. 1.86. What is the ratio of the Grants(current US$) in Mali in 1992 to that in 1997?
Give a very brief answer. 0.96. What is the ratio of the Grants(current US$) in Paraguay in 1992 to that in 1997?
Ensure brevity in your answer.  2. What is the ratio of the Grants(current US$) of Kenya in 1992 to that in 1998?
Offer a very short reply. 1.9. What is the ratio of the Grants(current US$) in Mali in 1992 to that in 1998?
Your response must be concise. 1.01. What is the ratio of the Grants(current US$) in Paraguay in 1992 to that in 1998?
Your answer should be very brief. 2.08. What is the ratio of the Grants(current US$) of Bermuda in 1992 to that in 1999?
Offer a very short reply. 11. What is the ratio of the Grants(current US$) in Kenya in 1992 to that in 1999?
Make the answer very short. 1.92. What is the ratio of the Grants(current US$) of Mali in 1992 to that in 1999?
Ensure brevity in your answer.  1.07. What is the ratio of the Grants(current US$) in Paraguay in 1992 to that in 1999?
Give a very brief answer. 1.37. What is the ratio of the Grants(current US$) of Bermuda in 1992 to that in 2000?
Keep it short and to the point. 3.67. What is the ratio of the Grants(current US$) in Kenya in 1992 to that in 2000?
Provide a short and direct response. 1.84. What is the ratio of the Grants(current US$) of Mali in 1992 to that in 2000?
Make the answer very short. 0.89. What is the ratio of the Grants(current US$) in Paraguay in 1992 to that in 2000?
Offer a very short reply. 1.73. What is the ratio of the Grants(current US$) in Bermuda in 1992 to that in 2003?
Your response must be concise. 11. What is the ratio of the Grants(current US$) in Kenya in 1992 to that in 2003?
Make the answer very short. 1.15. What is the ratio of the Grants(current US$) of Mali in 1992 to that in 2003?
Provide a succinct answer. 0.59. What is the ratio of the Grants(current US$) in Paraguay in 1992 to that in 2003?
Your answer should be compact. 2.44. What is the ratio of the Grants(current US$) of Kenya in 1995 to that in 1997?
Ensure brevity in your answer.  1.19. What is the ratio of the Grants(current US$) in Mali in 1995 to that in 1997?
Keep it short and to the point. 0.99. What is the ratio of the Grants(current US$) of Paraguay in 1995 to that in 1997?
Offer a terse response. 1.59. What is the ratio of the Grants(current US$) of Kenya in 1995 to that in 1998?
Make the answer very short. 1.22. What is the ratio of the Grants(current US$) in Mali in 1995 to that in 1998?
Provide a short and direct response. 1.04. What is the ratio of the Grants(current US$) of Paraguay in 1995 to that in 1998?
Ensure brevity in your answer.  1.66. What is the ratio of the Grants(current US$) of Kenya in 1995 to that in 1999?
Give a very brief answer. 1.23. What is the ratio of the Grants(current US$) in Mali in 1995 to that in 1999?
Offer a terse response. 1.1. What is the ratio of the Grants(current US$) in Paraguay in 1995 to that in 1999?
Your response must be concise. 1.09. What is the ratio of the Grants(current US$) in Kenya in 1995 to that in 2000?
Offer a very short reply. 1.18. What is the ratio of the Grants(current US$) of Mali in 1995 to that in 2000?
Provide a short and direct response. 0.91. What is the ratio of the Grants(current US$) in Paraguay in 1995 to that in 2000?
Provide a short and direct response. 1.38. What is the ratio of the Grants(current US$) of Kenya in 1995 to that in 2003?
Provide a succinct answer. 0.73. What is the ratio of the Grants(current US$) in Mali in 1995 to that in 2003?
Provide a succinct answer. 0.6. What is the ratio of the Grants(current US$) of Paraguay in 1995 to that in 2003?
Provide a short and direct response. 1.94. What is the ratio of the Grants(current US$) of Kenya in 1997 to that in 1998?
Keep it short and to the point. 1.02. What is the ratio of the Grants(current US$) of Mali in 1997 to that in 1998?
Provide a short and direct response. 1.05. What is the ratio of the Grants(current US$) of Paraguay in 1997 to that in 1998?
Ensure brevity in your answer.  1.04. What is the ratio of the Grants(current US$) of Kenya in 1997 to that in 1999?
Provide a succinct answer. 1.03. What is the ratio of the Grants(current US$) in Mali in 1997 to that in 1999?
Keep it short and to the point. 1.11. What is the ratio of the Grants(current US$) of Paraguay in 1997 to that in 1999?
Offer a very short reply. 0.68. What is the ratio of the Grants(current US$) in Bermuda in 1997 to that in 2000?
Ensure brevity in your answer.  0.33. What is the ratio of the Grants(current US$) in Kenya in 1997 to that in 2000?
Provide a short and direct response. 0.99. What is the ratio of the Grants(current US$) in Mali in 1997 to that in 2000?
Ensure brevity in your answer.  0.92. What is the ratio of the Grants(current US$) of Paraguay in 1997 to that in 2000?
Make the answer very short. 0.87. What is the ratio of the Grants(current US$) in Kenya in 1997 to that in 2003?
Keep it short and to the point. 0.61. What is the ratio of the Grants(current US$) in Mali in 1997 to that in 2003?
Your answer should be very brief. 0.61. What is the ratio of the Grants(current US$) of Paraguay in 1997 to that in 2003?
Your response must be concise. 1.22. What is the ratio of the Grants(current US$) in Bermuda in 1998 to that in 1999?
Offer a terse response. 1. What is the ratio of the Grants(current US$) of Kenya in 1998 to that in 1999?
Your answer should be very brief. 1.01. What is the ratio of the Grants(current US$) of Mali in 1998 to that in 1999?
Your answer should be compact. 1.06. What is the ratio of the Grants(current US$) in Paraguay in 1998 to that in 1999?
Offer a terse response. 0.66. What is the ratio of the Grants(current US$) of Bermuda in 1998 to that in 2000?
Your response must be concise. 0.33. What is the ratio of the Grants(current US$) in Kenya in 1998 to that in 2000?
Ensure brevity in your answer.  0.97. What is the ratio of the Grants(current US$) in Mali in 1998 to that in 2000?
Provide a short and direct response. 0.88. What is the ratio of the Grants(current US$) in Paraguay in 1998 to that in 2000?
Offer a terse response. 0.83. What is the ratio of the Grants(current US$) of Kenya in 1998 to that in 2003?
Your response must be concise. 0.6. What is the ratio of the Grants(current US$) of Mali in 1998 to that in 2003?
Make the answer very short. 0.58. What is the ratio of the Grants(current US$) in Paraguay in 1998 to that in 2003?
Provide a short and direct response. 1.17. What is the ratio of the Grants(current US$) in Bermuda in 1999 to that in 2000?
Keep it short and to the point. 0.33. What is the ratio of the Grants(current US$) in Kenya in 1999 to that in 2000?
Ensure brevity in your answer.  0.96. What is the ratio of the Grants(current US$) in Mali in 1999 to that in 2000?
Provide a short and direct response. 0.83. What is the ratio of the Grants(current US$) in Paraguay in 1999 to that in 2000?
Provide a short and direct response. 1.27. What is the ratio of the Grants(current US$) of Bermuda in 1999 to that in 2003?
Offer a terse response. 1. What is the ratio of the Grants(current US$) in Kenya in 1999 to that in 2003?
Offer a terse response. 0.6. What is the ratio of the Grants(current US$) in Mali in 1999 to that in 2003?
Make the answer very short. 0.55. What is the ratio of the Grants(current US$) in Paraguay in 1999 to that in 2003?
Provide a short and direct response. 1.78. What is the ratio of the Grants(current US$) in Kenya in 2000 to that in 2003?
Your answer should be compact. 0.62. What is the ratio of the Grants(current US$) in Mali in 2000 to that in 2003?
Keep it short and to the point. 0.66. What is the ratio of the Grants(current US$) of Paraguay in 2000 to that in 2003?
Give a very brief answer. 1.4. What is the difference between the highest and the second highest Grants(current US$) in Bermuda?
Provide a succinct answer. 10000. What is the difference between the highest and the second highest Grants(current US$) of Kenya?
Provide a short and direct response. 5.99e+08. What is the difference between the highest and the second highest Grants(current US$) of Mali?
Offer a terse response. 1.18e+08. What is the difference between the highest and the second highest Grants(current US$) of Paraguay?
Provide a short and direct response. 9.10e+06. What is the difference between the highest and the lowest Grants(current US$) of Bermuda?
Ensure brevity in your answer.  1.10e+05. What is the difference between the highest and the lowest Grants(current US$) in Kenya?
Provide a short and direct response. 7.80e+08. What is the difference between the highest and the lowest Grants(current US$) in Mali?
Offer a terse response. 1.57e+08. What is the difference between the highest and the lowest Grants(current US$) of Paraguay?
Offer a very short reply. 3.69e+07. 